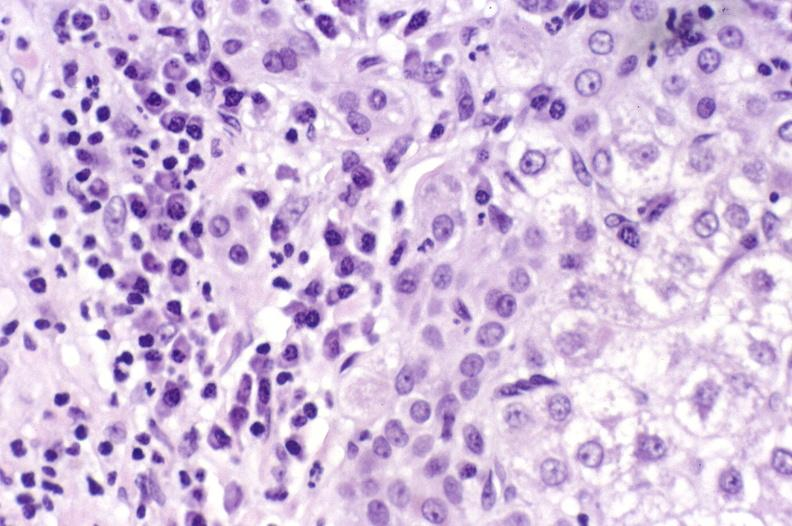what is present?
Answer the question using a single word or phrase. Hepatobiliary 